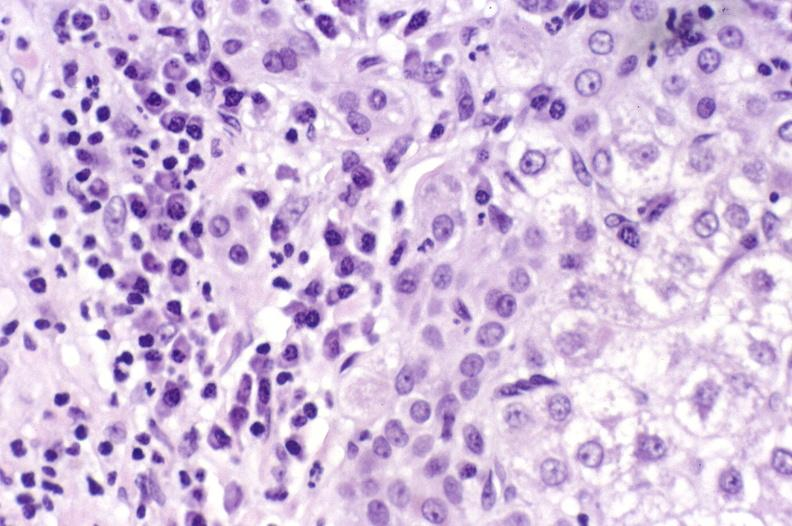what is present?
Answer the question using a single word or phrase. Hepatobiliary 